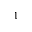<formula> <loc_0><loc_0><loc_500><loc_500>^ { 1 }</formula> 